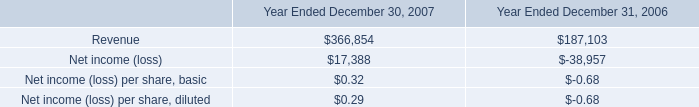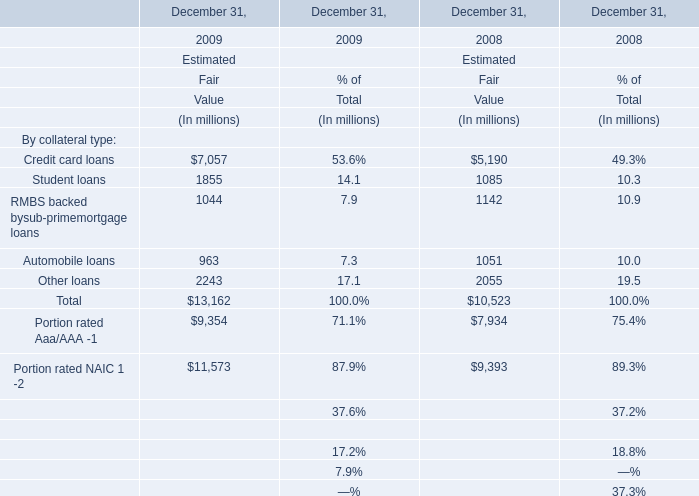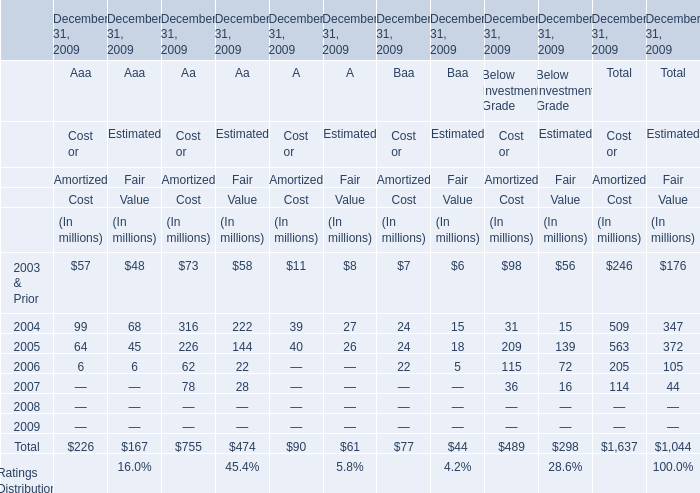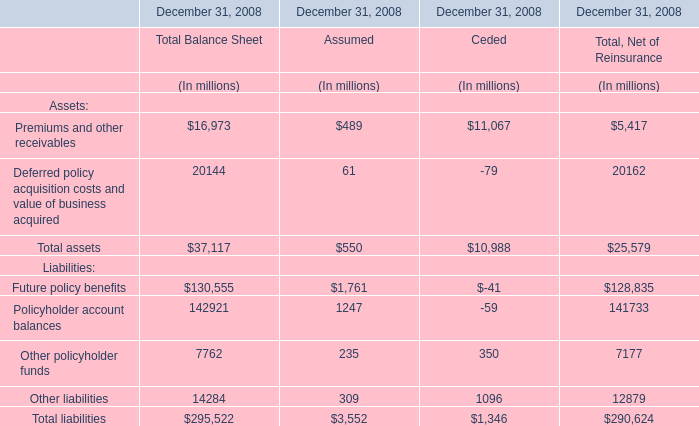If Cost or Amortized Cost for Aaa develops with the same growth rate in 2005, what will it reach in 2006? (in million) 
Computations: (64 * (1 + ((64 - 99) / 99)))
Answer: 41.37374. 